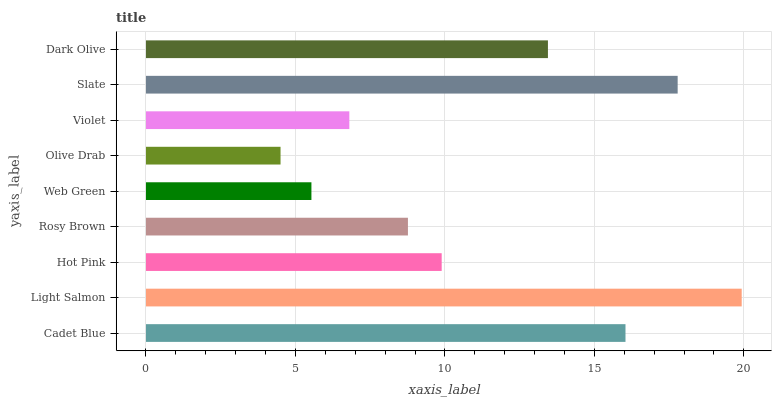Is Olive Drab the minimum?
Answer yes or no. Yes. Is Light Salmon the maximum?
Answer yes or no. Yes. Is Hot Pink the minimum?
Answer yes or no. No. Is Hot Pink the maximum?
Answer yes or no. No. Is Light Salmon greater than Hot Pink?
Answer yes or no. Yes. Is Hot Pink less than Light Salmon?
Answer yes or no. Yes. Is Hot Pink greater than Light Salmon?
Answer yes or no. No. Is Light Salmon less than Hot Pink?
Answer yes or no. No. Is Hot Pink the high median?
Answer yes or no. Yes. Is Hot Pink the low median?
Answer yes or no. Yes. Is Dark Olive the high median?
Answer yes or no. No. Is Dark Olive the low median?
Answer yes or no. No. 